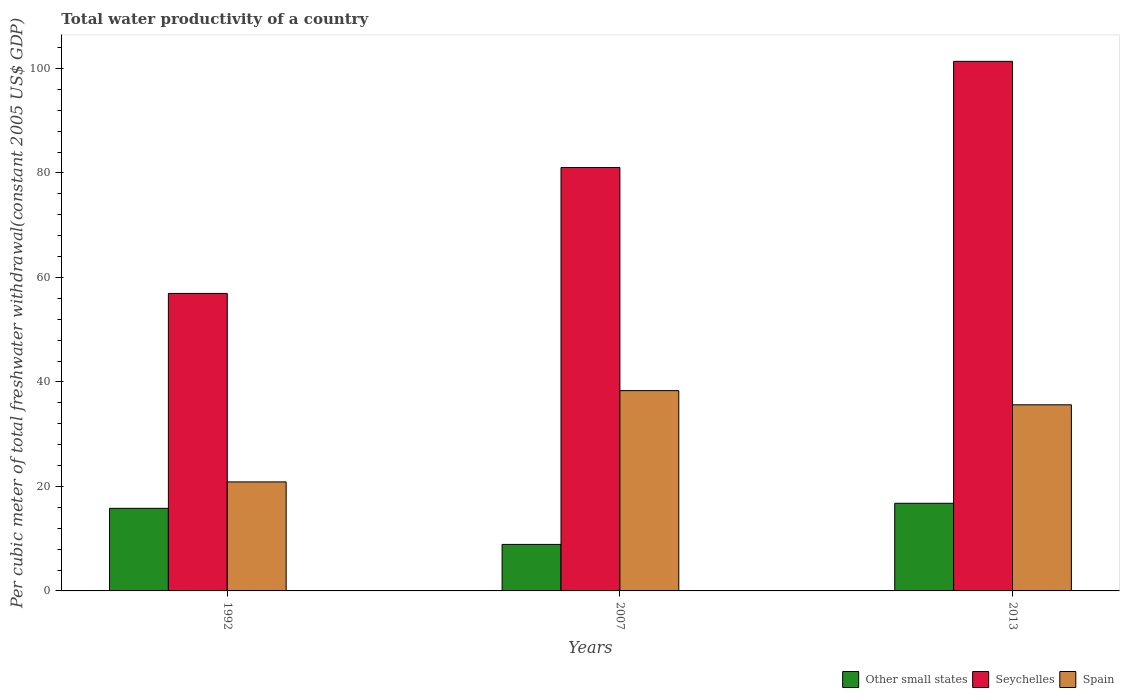Are the number of bars per tick equal to the number of legend labels?
Provide a short and direct response. Yes. How many bars are there on the 3rd tick from the left?
Provide a short and direct response. 3. How many bars are there on the 1st tick from the right?
Ensure brevity in your answer.  3. What is the label of the 2nd group of bars from the left?
Your response must be concise. 2007. In how many cases, is the number of bars for a given year not equal to the number of legend labels?
Provide a short and direct response. 0. What is the total water productivity in Spain in 2013?
Offer a very short reply. 35.63. Across all years, what is the maximum total water productivity in Spain?
Make the answer very short. 38.34. Across all years, what is the minimum total water productivity in Spain?
Ensure brevity in your answer.  20.87. What is the total total water productivity in Other small states in the graph?
Provide a short and direct response. 41.49. What is the difference between the total water productivity in Spain in 2007 and that in 2013?
Provide a short and direct response. 2.71. What is the difference between the total water productivity in Seychelles in 1992 and the total water productivity in Spain in 2013?
Your response must be concise. 21.32. What is the average total water productivity in Seychelles per year?
Give a very brief answer. 79.78. In the year 1992, what is the difference between the total water productivity in Other small states and total water productivity in Seychelles?
Your answer should be very brief. -41.14. In how many years, is the total water productivity in Other small states greater than 32 US$?
Give a very brief answer. 0. What is the ratio of the total water productivity in Spain in 2007 to that in 2013?
Keep it short and to the point. 1.08. Is the total water productivity in Spain in 2007 less than that in 2013?
Make the answer very short. No. Is the difference between the total water productivity in Other small states in 1992 and 2013 greater than the difference between the total water productivity in Seychelles in 1992 and 2013?
Offer a terse response. Yes. What is the difference between the highest and the second highest total water productivity in Seychelles?
Provide a short and direct response. 20.32. What is the difference between the highest and the lowest total water productivity in Spain?
Give a very brief answer. 17.47. In how many years, is the total water productivity in Other small states greater than the average total water productivity in Other small states taken over all years?
Ensure brevity in your answer.  2. What does the 2nd bar from the left in 2007 represents?
Make the answer very short. Seychelles. What does the 2nd bar from the right in 2013 represents?
Make the answer very short. Seychelles. How many bars are there?
Your response must be concise. 9. How many years are there in the graph?
Ensure brevity in your answer.  3. What is the difference between two consecutive major ticks on the Y-axis?
Ensure brevity in your answer.  20. Are the values on the major ticks of Y-axis written in scientific E-notation?
Offer a very short reply. No. Does the graph contain any zero values?
Your answer should be compact. No. How many legend labels are there?
Make the answer very short. 3. How are the legend labels stacked?
Keep it short and to the point. Horizontal. What is the title of the graph?
Your response must be concise. Total water productivity of a country. What is the label or title of the X-axis?
Provide a short and direct response. Years. What is the label or title of the Y-axis?
Keep it short and to the point. Per cubic meter of total freshwater withdrawal(constant 2005 US$ GDP). What is the Per cubic meter of total freshwater withdrawal(constant 2005 US$ GDP) in Other small states in 1992?
Provide a succinct answer. 15.81. What is the Per cubic meter of total freshwater withdrawal(constant 2005 US$ GDP) of Seychelles in 1992?
Your answer should be very brief. 56.94. What is the Per cubic meter of total freshwater withdrawal(constant 2005 US$ GDP) of Spain in 1992?
Your response must be concise. 20.87. What is the Per cubic meter of total freshwater withdrawal(constant 2005 US$ GDP) of Other small states in 2007?
Keep it short and to the point. 8.9. What is the Per cubic meter of total freshwater withdrawal(constant 2005 US$ GDP) in Seychelles in 2007?
Give a very brief answer. 81.04. What is the Per cubic meter of total freshwater withdrawal(constant 2005 US$ GDP) of Spain in 2007?
Give a very brief answer. 38.34. What is the Per cubic meter of total freshwater withdrawal(constant 2005 US$ GDP) in Other small states in 2013?
Make the answer very short. 16.78. What is the Per cubic meter of total freshwater withdrawal(constant 2005 US$ GDP) of Seychelles in 2013?
Offer a very short reply. 101.37. What is the Per cubic meter of total freshwater withdrawal(constant 2005 US$ GDP) of Spain in 2013?
Your response must be concise. 35.63. Across all years, what is the maximum Per cubic meter of total freshwater withdrawal(constant 2005 US$ GDP) in Other small states?
Give a very brief answer. 16.78. Across all years, what is the maximum Per cubic meter of total freshwater withdrawal(constant 2005 US$ GDP) in Seychelles?
Give a very brief answer. 101.37. Across all years, what is the maximum Per cubic meter of total freshwater withdrawal(constant 2005 US$ GDP) of Spain?
Keep it short and to the point. 38.34. Across all years, what is the minimum Per cubic meter of total freshwater withdrawal(constant 2005 US$ GDP) in Other small states?
Make the answer very short. 8.9. Across all years, what is the minimum Per cubic meter of total freshwater withdrawal(constant 2005 US$ GDP) in Seychelles?
Your response must be concise. 56.94. Across all years, what is the minimum Per cubic meter of total freshwater withdrawal(constant 2005 US$ GDP) of Spain?
Offer a terse response. 20.87. What is the total Per cubic meter of total freshwater withdrawal(constant 2005 US$ GDP) of Other small states in the graph?
Provide a succinct answer. 41.49. What is the total Per cubic meter of total freshwater withdrawal(constant 2005 US$ GDP) in Seychelles in the graph?
Your response must be concise. 239.35. What is the total Per cubic meter of total freshwater withdrawal(constant 2005 US$ GDP) in Spain in the graph?
Your answer should be compact. 94.84. What is the difference between the Per cubic meter of total freshwater withdrawal(constant 2005 US$ GDP) of Other small states in 1992 and that in 2007?
Offer a terse response. 6.9. What is the difference between the Per cubic meter of total freshwater withdrawal(constant 2005 US$ GDP) of Seychelles in 1992 and that in 2007?
Offer a very short reply. -24.1. What is the difference between the Per cubic meter of total freshwater withdrawal(constant 2005 US$ GDP) of Spain in 1992 and that in 2007?
Provide a succinct answer. -17.47. What is the difference between the Per cubic meter of total freshwater withdrawal(constant 2005 US$ GDP) in Other small states in 1992 and that in 2013?
Your answer should be very brief. -0.97. What is the difference between the Per cubic meter of total freshwater withdrawal(constant 2005 US$ GDP) in Seychelles in 1992 and that in 2013?
Keep it short and to the point. -44.42. What is the difference between the Per cubic meter of total freshwater withdrawal(constant 2005 US$ GDP) of Spain in 1992 and that in 2013?
Offer a very short reply. -14.76. What is the difference between the Per cubic meter of total freshwater withdrawal(constant 2005 US$ GDP) of Other small states in 2007 and that in 2013?
Your answer should be compact. -7.87. What is the difference between the Per cubic meter of total freshwater withdrawal(constant 2005 US$ GDP) of Seychelles in 2007 and that in 2013?
Your response must be concise. -20.32. What is the difference between the Per cubic meter of total freshwater withdrawal(constant 2005 US$ GDP) in Spain in 2007 and that in 2013?
Your answer should be compact. 2.71. What is the difference between the Per cubic meter of total freshwater withdrawal(constant 2005 US$ GDP) of Other small states in 1992 and the Per cubic meter of total freshwater withdrawal(constant 2005 US$ GDP) of Seychelles in 2007?
Offer a very short reply. -65.24. What is the difference between the Per cubic meter of total freshwater withdrawal(constant 2005 US$ GDP) of Other small states in 1992 and the Per cubic meter of total freshwater withdrawal(constant 2005 US$ GDP) of Spain in 2007?
Keep it short and to the point. -22.53. What is the difference between the Per cubic meter of total freshwater withdrawal(constant 2005 US$ GDP) in Seychelles in 1992 and the Per cubic meter of total freshwater withdrawal(constant 2005 US$ GDP) in Spain in 2007?
Your response must be concise. 18.6. What is the difference between the Per cubic meter of total freshwater withdrawal(constant 2005 US$ GDP) in Other small states in 1992 and the Per cubic meter of total freshwater withdrawal(constant 2005 US$ GDP) in Seychelles in 2013?
Offer a terse response. -85.56. What is the difference between the Per cubic meter of total freshwater withdrawal(constant 2005 US$ GDP) in Other small states in 1992 and the Per cubic meter of total freshwater withdrawal(constant 2005 US$ GDP) in Spain in 2013?
Keep it short and to the point. -19.82. What is the difference between the Per cubic meter of total freshwater withdrawal(constant 2005 US$ GDP) in Seychelles in 1992 and the Per cubic meter of total freshwater withdrawal(constant 2005 US$ GDP) in Spain in 2013?
Your answer should be compact. 21.32. What is the difference between the Per cubic meter of total freshwater withdrawal(constant 2005 US$ GDP) in Other small states in 2007 and the Per cubic meter of total freshwater withdrawal(constant 2005 US$ GDP) in Seychelles in 2013?
Give a very brief answer. -92.46. What is the difference between the Per cubic meter of total freshwater withdrawal(constant 2005 US$ GDP) of Other small states in 2007 and the Per cubic meter of total freshwater withdrawal(constant 2005 US$ GDP) of Spain in 2013?
Your answer should be very brief. -26.72. What is the difference between the Per cubic meter of total freshwater withdrawal(constant 2005 US$ GDP) in Seychelles in 2007 and the Per cubic meter of total freshwater withdrawal(constant 2005 US$ GDP) in Spain in 2013?
Provide a short and direct response. 45.42. What is the average Per cubic meter of total freshwater withdrawal(constant 2005 US$ GDP) in Other small states per year?
Give a very brief answer. 13.83. What is the average Per cubic meter of total freshwater withdrawal(constant 2005 US$ GDP) in Seychelles per year?
Your response must be concise. 79.78. What is the average Per cubic meter of total freshwater withdrawal(constant 2005 US$ GDP) in Spain per year?
Your answer should be compact. 31.61. In the year 1992, what is the difference between the Per cubic meter of total freshwater withdrawal(constant 2005 US$ GDP) of Other small states and Per cubic meter of total freshwater withdrawal(constant 2005 US$ GDP) of Seychelles?
Keep it short and to the point. -41.14. In the year 1992, what is the difference between the Per cubic meter of total freshwater withdrawal(constant 2005 US$ GDP) in Other small states and Per cubic meter of total freshwater withdrawal(constant 2005 US$ GDP) in Spain?
Offer a terse response. -5.06. In the year 1992, what is the difference between the Per cubic meter of total freshwater withdrawal(constant 2005 US$ GDP) in Seychelles and Per cubic meter of total freshwater withdrawal(constant 2005 US$ GDP) in Spain?
Offer a very short reply. 36.07. In the year 2007, what is the difference between the Per cubic meter of total freshwater withdrawal(constant 2005 US$ GDP) of Other small states and Per cubic meter of total freshwater withdrawal(constant 2005 US$ GDP) of Seychelles?
Your response must be concise. -72.14. In the year 2007, what is the difference between the Per cubic meter of total freshwater withdrawal(constant 2005 US$ GDP) in Other small states and Per cubic meter of total freshwater withdrawal(constant 2005 US$ GDP) in Spain?
Your answer should be compact. -29.44. In the year 2007, what is the difference between the Per cubic meter of total freshwater withdrawal(constant 2005 US$ GDP) of Seychelles and Per cubic meter of total freshwater withdrawal(constant 2005 US$ GDP) of Spain?
Your answer should be very brief. 42.7. In the year 2013, what is the difference between the Per cubic meter of total freshwater withdrawal(constant 2005 US$ GDP) in Other small states and Per cubic meter of total freshwater withdrawal(constant 2005 US$ GDP) in Seychelles?
Offer a very short reply. -84.59. In the year 2013, what is the difference between the Per cubic meter of total freshwater withdrawal(constant 2005 US$ GDP) of Other small states and Per cubic meter of total freshwater withdrawal(constant 2005 US$ GDP) of Spain?
Provide a short and direct response. -18.85. In the year 2013, what is the difference between the Per cubic meter of total freshwater withdrawal(constant 2005 US$ GDP) in Seychelles and Per cubic meter of total freshwater withdrawal(constant 2005 US$ GDP) in Spain?
Your answer should be compact. 65.74. What is the ratio of the Per cubic meter of total freshwater withdrawal(constant 2005 US$ GDP) of Other small states in 1992 to that in 2007?
Ensure brevity in your answer.  1.78. What is the ratio of the Per cubic meter of total freshwater withdrawal(constant 2005 US$ GDP) of Seychelles in 1992 to that in 2007?
Provide a short and direct response. 0.7. What is the ratio of the Per cubic meter of total freshwater withdrawal(constant 2005 US$ GDP) of Spain in 1992 to that in 2007?
Offer a very short reply. 0.54. What is the ratio of the Per cubic meter of total freshwater withdrawal(constant 2005 US$ GDP) of Other small states in 1992 to that in 2013?
Make the answer very short. 0.94. What is the ratio of the Per cubic meter of total freshwater withdrawal(constant 2005 US$ GDP) of Seychelles in 1992 to that in 2013?
Offer a terse response. 0.56. What is the ratio of the Per cubic meter of total freshwater withdrawal(constant 2005 US$ GDP) in Spain in 1992 to that in 2013?
Offer a very short reply. 0.59. What is the ratio of the Per cubic meter of total freshwater withdrawal(constant 2005 US$ GDP) of Other small states in 2007 to that in 2013?
Ensure brevity in your answer.  0.53. What is the ratio of the Per cubic meter of total freshwater withdrawal(constant 2005 US$ GDP) of Seychelles in 2007 to that in 2013?
Provide a short and direct response. 0.8. What is the ratio of the Per cubic meter of total freshwater withdrawal(constant 2005 US$ GDP) of Spain in 2007 to that in 2013?
Offer a very short reply. 1.08. What is the difference between the highest and the second highest Per cubic meter of total freshwater withdrawal(constant 2005 US$ GDP) of Other small states?
Ensure brevity in your answer.  0.97. What is the difference between the highest and the second highest Per cubic meter of total freshwater withdrawal(constant 2005 US$ GDP) of Seychelles?
Offer a very short reply. 20.32. What is the difference between the highest and the second highest Per cubic meter of total freshwater withdrawal(constant 2005 US$ GDP) of Spain?
Keep it short and to the point. 2.71. What is the difference between the highest and the lowest Per cubic meter of total freshwater withdrawal(constant 2005 US$ GDP) in Other small states?
Your answer should be very brief. 7.87. What is the difference between the highest and the lowest Per cubic meter of total freshwater withdrawal(constant 2005 US$ GDP) of Seychelles?
Offer a very short reply. 44.42. What is the difference between the highest and the lowest Per cubic meter of total freshwater withdrawal(constant 2005 US$ GDP) of Spain?
Provide a short and direct response. 17.47. 